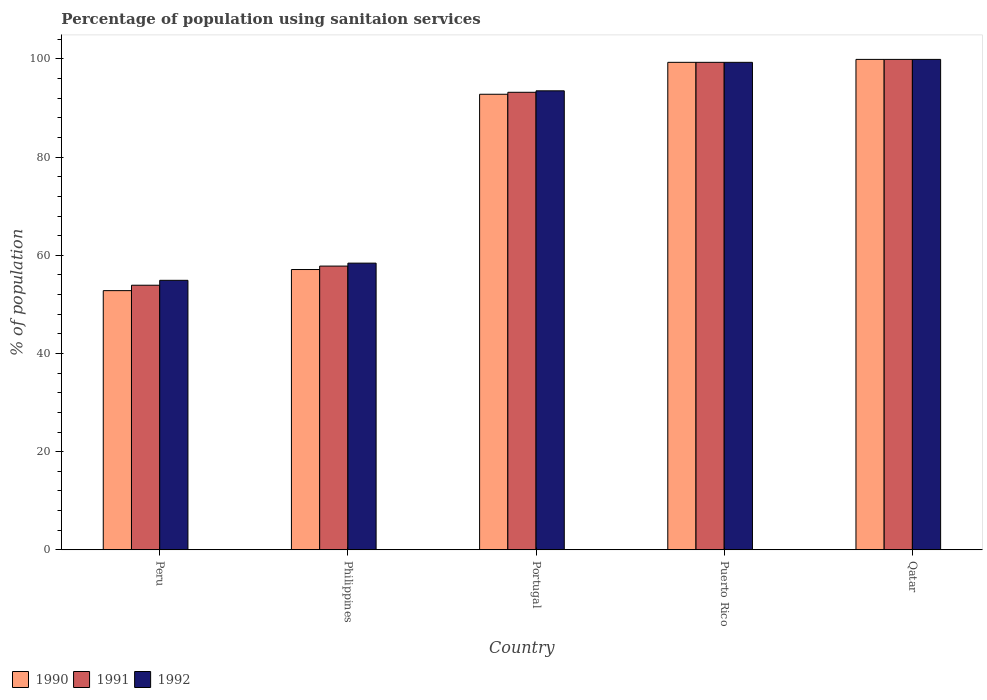How many different coloured bars are there?
Keep it short and to the point. 3. What is the label of the 5th group of bars from the left?
Provide a succinct answer. Qatar. In how many cases, is the number of bars for a given country not equal to the number of legend labels?
Give a very brief answer. 0. What is the percentage of population using sanitaion services in 1990 in Peru?
Provide a short and direct response. 52.8. Across all countries, what is the maximum percentage of population using sanitaion services in 1990?
Give a very brief answer. 99.9. Across all countries, what is the minimum percentage of population using sanitaion services in 1992?
Offer a very short reply. 54.9. In which country was the percentage of population using sanitaion services in 1992 maximum?
Ensure brevity in your answer.  Qatar. What is the total percentage of population using sanitaion services in 1991 in the graph?
Give a very brief answer. 404.1. What is the difference between the percentage of population using sanitaion services in 1991 in Peru and that in Puerto Rico?
Give a very brief answer. -45.4. What is the difference between the percentage of population using sanitaion services in 1990 in Peru and the percentage of population using sanitaion services in 1991 in Philippines?
Make the answer very short. -5. What is the average percentage of population using sanitaion services in 1992 per country?
Provide a short and direct response. 81.2. What is the difference between the percentage of population using sanitaion services of/in 1990 and percentage of population using sanitaion services of/in 1992 in Philippines?
Your answer should be very brief. -1.3. In how many countries, is the percentage of population using sanitaion services in 1990 greater than 12 %?
Provide a short and direct response. 5. What is the ratio of the percentage of population using sanitaion services in 1991 in Peru to that in Portugal?
Give a very brief answer. 0.58. Is the difference between the percentage of population using sanitaion services in 1990 in Peru and Puerto Rico greater than the difference between the percentage of population using sanitaion services in 1992 in Peru and Puerto Rico?
Your answer should be very brief. No. What is the difference between the highest and the second highest percentage of population using sanitaion services in 1992?
Offer a terse response. -0.6. What is the difference between the highest and the lowest percentage of population using sanitaion services in 1990?
Your answer should be compact. 47.1. Is the sum of the percentage of population using sanitaion services in 1992 in Philippines and Puerto Rico greater than the maximum percentage of population using sanitaion services in 1991 across all countries?
Ensure brevity in your answer.  Yes. What does the 2nd bar from the left in Peru represents?
Your response must be concise. 1991. Are all the bars in the graph horizontal?
Offer a very short reply. No. What is the difference between two consecutive major ticks on the Y-axis?
Ensure brevity in your answer.  20. Are the values on the major ticks of Y-axis written in scientific E-notation?
Give a very brief answer. No. How many legend labels are there?
Your answer should be compact. 3. How are the legend labels stacked?
Your answer should be compact. Horizontal. What is the title of the graph?
Your answer should be very brief. Percentage of population using sanitaion services. Does "2003" appear as one of the legend labels in the graph?
Provide a succinct answer. No. What is the label or title of the X-axis?
Offer a very short reply. Country. What is the label or title of the Y-axis?
Ensure brevity in your answer.  % of population. What is the % of population in 1990 in Peru?
Ensure brevity in your answer.  52.8. What is the % of population of 1991 in Peru?
Provide a short and direct response. 53.9. What is the % of population in 1992 in Peru?
Your answer should be very brief. 54.9. What is the % of population in 1990 in Philippines?
Ensure brevity in your answer.  57.1. What is the % of population of 1991 in Philippines?
Your answer should be compact. 57.8. What is the % of population of 1992 in Philippines?
Your answer should be compact. 58.4. What is the % of population of 1990 in Portugal?
Your response must be concise. 92.8. What is the % of population in 1991 in Portugal?
Give a very brief answer. 93.2. What is the % of population in 1992 in Portugal?
Make the answer very short. 93.5. What is the % of population in 1990 in Puerto Rico?
Keep it short and to the point. 99.3. What is the % of population of 1991 in Puerto Rico?
Your answer should be compact. 99.3. What is the % of population in 1992 in Puerto Rico?
Your answer should be very brief. 99.3. What is the % of population of 1990 in Qatar?
Offer a terse response. 99.9. What is the % of population of 1991 in Qatar?
Offer a very short reply. 99.9. What is the % of population in 1992 in Qatar?
Your answer should be very brief. 99.9. Across all countries, what is the maximum % of population of 1990?
Provide a short and direct response. 99.9. Across all countries, what is the maximum % of population of 1991?
Provide a succinct answer. 99.9. Across all countries, what is the maximum % of population of 1992?
Your answer should be compact. 99.9. Across all countries, what is the minimum % of population of 1990?
Offer a terse response. 52.8. Across all countries, what is the minimum % of population of 1991?
Give a very brief answer. 53.9. Across all countries, what is the minimum % of population in 1992?
Provide a succinct answer. 54.9. What is the total % of population of 1990 in the graph?
Keep it short and to the point. 401.9. What is the total % of population of 1991 in the graph?
Your answer should be compact. 404.1. What is the total % of population of 1992 in the graph?
Offer a very short reply. 406. What is the difference between the % of population of 1991 in Peru and that in Philippines?
Provide a succinct answer. -3.9. What is the difference between the % of population of 1992 in Peru and that in Philippines?
Your answer should be very brief. -3.5. What is the difference between the % of population in 1991 in Peru and that in Portugal?
Your answer should be compact. -39.3. What is the difference between the % of population in 1992 in Peru and that in Portugal?
Your answer should be compact. -38.6. What is the difference between the % of population in 1990 in Peru and that in Puerto Rico?
Offer a terse response. -46.5. What is the difference between the % of population in 1991 in Peru and that in Puerto Rico?
Make the answer very short. -45.4. What is the difference between the % of population of 1992 in Peru and that in Puerto Rico?
Offer a very short reply. -44.4. What is the difference between the % of population in 1990 in Peru and that in Qatar?
Your answer should be very brief. -47.1. What is the difference between the % of population in 1991 in Peru and that in Qatar?
Keep it short and to the point. -46. What is the difference between the % of population of 1992 in Peru and that in Qatar?
Offer a terse response. -45. What is the difference between the % of population of 1990 in Philippines and that in Portugal?
Provide a succinct answer. -35.7. What is the difference between the % of population of 1991 in Philippines and that in Portugal?
Make the answer very short. -35.4. What is the difference between the % of population of 1992 in Philippines and that in Portugal?
Give a very brief answer. -35.1. What is the difference between the % of population of 1990 in Philippines and that in Puerto Rico?
Offer a very short reply. -42.2. What is the difference between the % of population in 1991 in Philippines and that in Puerto Rico?
Give a very brief answer. -41.5. What is the difference between the % of population in 1992 in Philippines and that in Puerto Rico?
Keep it short and to the point. -40.9. What is the difference between the % of population in 1990 in Philippines and that in Qatar?
Offer a very short reply. -42.8. What is the difference between the % of population in 1991 in Philippines and that in Qatar?
Offer a terse response. -42.1. What is the difference between the % of population in 1992 in Philippines and that in Qatar?
Give a very brief answer. -41.5. What is the difference between the % of population in 1991 in Portugal and that in Puerto Rico?
Your answer should be very brief. -6.1. What is the difference between the % of population in 1992 in Portugal and that in Puerto Rico?
Offer a very short reply. -5.8. What is the difference between the % of population in 1990 in Portugal and that in Qatar?
Make the answer very short. -7.1. What is the difference between the % of population of 1991 in Portugal and that in Qatar?
Keep it short and to the point. -6.7. What is the difference between the % of population of 1992 in Portugal and that in Qatar?
Offer a terse response. -6.4. What is the difference between the % of population in 1991 in Puerto Rico and that in Qatar?
Your answer should be compact. -0.6. What is the difference between the % of population of 1992 in Puerto Rico and that in Qatar?
Provide a short and direct response. -0.6. What is the difference between the % of population of 1990 in Peru and the % of population of 1992 in Philippines?
Provide a succinct answer. -5.6. What is the difference between the % of population in 1990 in Peru and the % of population in 1991 in Portugal?
Provide a short and direct response. -40.4. What is the difference between the % of population of 1990 in Peru and the % of population of 1992 in Portugal?
Your response must be concise. -40.7. What is the difference between the % of population in 1991 in Peru and the % of population in 1992 in Portugal?
Your response must be concise. -39.6. What is the difference between the % of population in 1990 in Peru and the % of population in 1991 in Puerto Rico?
Make the answer very short. -46.5. What is the difference between the % of population of 1990 in Peru and the % of population of 1992 in Puerto Rico?
Offer a terse response. -46.5. What is the difference between the % of population of 1991 in Peru and the % of population of 1992 in Puerto Rico?
Offer a very short reply. -45.4. What is the difference between the % of population of 1990 in Peru and the % of population of 1991 in Qatar?
Offer a very short reply. -47.1. What is the difference between the % of population in 1990 in Peru and the % of population in 1992 in Qatar?
Ensure brevity in your answer.  -47.1. What is the difference between the % of population in 1991 in Peru and the % of population in 1992 in Qatar?
Give a very brief answer. -46. What is the difference between the % of population in 1990 in Philippines and the % of population in 1991 in Portugal?
Provide a short and direct response. -36.1. What is the difference between the % of population in 1990 in Philippines and the % of population in 1992 in Portugal?
Offer a very short reply. -36.4. What is the difference between the % of population of 1991 in Philippines and the % of population of 1992 in Portugal?
Offer a very short reply. -35.7. What is the difference between the % of population of 1990 in Philippines and the % of population of 1991 in Puerto Rico?
Provide a succinct answer. -42.2. What is the difference between the % of population in 1990 in Philippines and the % of population in 1992 in Puerto Rico?
Your answer should be very brief. -42.2. What is the difference between the % of population in 1991 in Philippines and the % of population in 1992 in Puerto Rico?
Make the answer very short. -41.5. What is the difference between the % of population of 1990 in Philippines and the % of population of 1991 in Qatar?
Offer a very short reply. -42.8. What is the difference between the % of population in 1990 in Philippines and the % of population in 1992 in Qatar?
Make the answer very short. -42.8. What is the difference between the % of population in 1991 in Philippines and the % of population in 1992 in Qatar?
Provide a succinct answer. -42.1. What is the difference between the % of population in 1990 in Portugal and the % of population in 1991 in Qatar?
Your response must be concise. -7.1. What is the difference between the % of population in 1990 in Portugal and the % of population in 1992 in Qatar?
Make the answer very short. -7.1. What is the difference between the % of population of 1990 in Puerto Rico and the % of population of 1991 in Qatar?
Make the answer very short. -0.6. What is the difference between the % of population in 1991 in Puerto Rico and the % of population in 1992 in Qatar?
Provide a short and direct response. -0.6. What is the average % of population in 1990 per country?
Your answer should be very brief. 80.38. What is the average % of population of 1991 per country?
Make the answer very short. 80.82. What is the average % of population of 1992 per country?
Ensure brevity in your answer.  81.2. What is the difference between the % of population of 1990 and % of population of 1991 in Peru?
Offer a very short reply. -1.1. What is the difference between the % of population of 1990 and % of population of 1992 in Peru?
Provide a short and direct response. -2.1. What is the difference between the % of population of 1991 and % of population of 1992 in Peru?
Your answer should be very brief. -1. What is the difference between the % of population of 1990 and % of population of 1992 in Philippines?
Your response must be concise. -1.3. What is the difference between the % of population of 1990 and % of population of 1991 in Portugal?
Provide a short and direct response. -0.4. What is the difference between the % of population of 1990 and % of population of 1991 in Puerto Rico?
Your answer should be very brief. 0. What is the difference between the % of population in 1990 and % of population in 1992 in Puerto Rico?
Ensure brevity in your answer.  0. What is the difference between the % of population of 1990 and % of population of 1991 in Qatar?
Ensure brevity in your answer.  0. What is the difference between the % of population of 1991 and % of population of 1992 in Qatar?
Your response must be concise. 0. What is the ratio of the % of population in 1990 in Peru to that in Philippines?
Offer a terse response. 0.92. What is the ratio of the % of population of 1991 in Peru to that in Philippines?
Your answer should be very brief. 0.93. What is the ratio of the % of population in 1992 in Peru to that in Philippines?
Your answer should be very brief. 0.94. What is the ratio of the % of population in 1990 in Peru to that in Portugal?
Make the answer very short. 0.57. What is the ratio of the % of population of 1991 in Peru to that in Portugal?
Offer a very short reply. 0.58. What is the ratio of the % of population in 1992 in Peru to that in Portugal?
Make the answer very short. 0.59. What is the ratio of the % of population in 1990 in Peru to that in Puerto Rico?
Your answer should be compact. 0.53. What is the ratio of the % of population of 1991 in Peru to that in Puerto Rico?
Offer a terse response. 0.54. What is the ratio of the % of population of 1992 in Peru to that in Puerto Rico?
Keep it short and to the point. 0.55. What is the ratio of the % of population in 1990 in Peru to that in Qatar?
Give a very brief answer. 0.53. What is the ratio of the % of population of 1991 in Peru to that in Qatar?
Your answer should be compact. 0.54. What is the ratio of the % of population of 1992 in Peru to that in Qatar?
Your answer should be compact. 0.55. What is the ratio of the % of population of 1990 in Philippines to that in Portugal?
Your answer should be very brief. 0.62. What is the ratio of the % of population of 1991 in Philippines to that in Portugal?
Your response must be concise. 0.62. What is the ratio of the % of population of 1992 in Philippines to that in Portugal?
Offer a terse response. 0.62. What is the ratio of the % of population in 1990 in Philippines to that in Puerto Rico?
Make the answer very short. 0.57. What is the ratio of the % of population of 1991 in Philippines to that in Puerto Rico?
Provide a short and direct response. 0.58. What is the ratio of the % of population of 1992 in Philippines to that in Puerto Rico?
Provide a short and direct response. 0.59. What is the ratio of the % of population of 1990 in Philippines to that in Qatar?
Your answer should be compact. 0.57. What is the ratio of the % of population of 1991 in Philippines to that in Qatar?
Keep it short and to the point. 0.58. What is the ratio of the % of population in 1992 in Philippines to that in Qatar?
Offer a very short reply. 0.58. What is the ratio of the % of population in 1990 in Portugal to that in Puerto Rico?
Give a very brief answer. 0.93. What is the ratio of the % of population in 1991 in Portugal to that in Puerto Rico?
Make the answer very short. 0.94. What is the ratio of the % of population in 1992 in Portugal to that in Puerto Rico?
Your answer should be very brief. 0.94. What is the ratio of the % of population of 1990 in Portugal to that in Qatar?
Your response must be concise. 0.93. What is the ratio of the % of population of 1991 in Portugal to that in Qatar?
Your answer should be very brief. 0.93. What is the ratio of the % of population of 1992 in Portugal to that in Qatar?
Provide a short and direct response. 0.94. What is the difference between the highest and the second highest % of population of 1990?
Offer a very short reply. 0.6. What is the difference between the highest and the second highest % of population in 1991?
Provide a succinct answer. 0.6. What is the difference between the highest and the lowest % of population of 1990?
Offer a terse response. 47.1. What is the difference between the highest and the lowest % of population of 1992?
Your response must be concise. 45. 